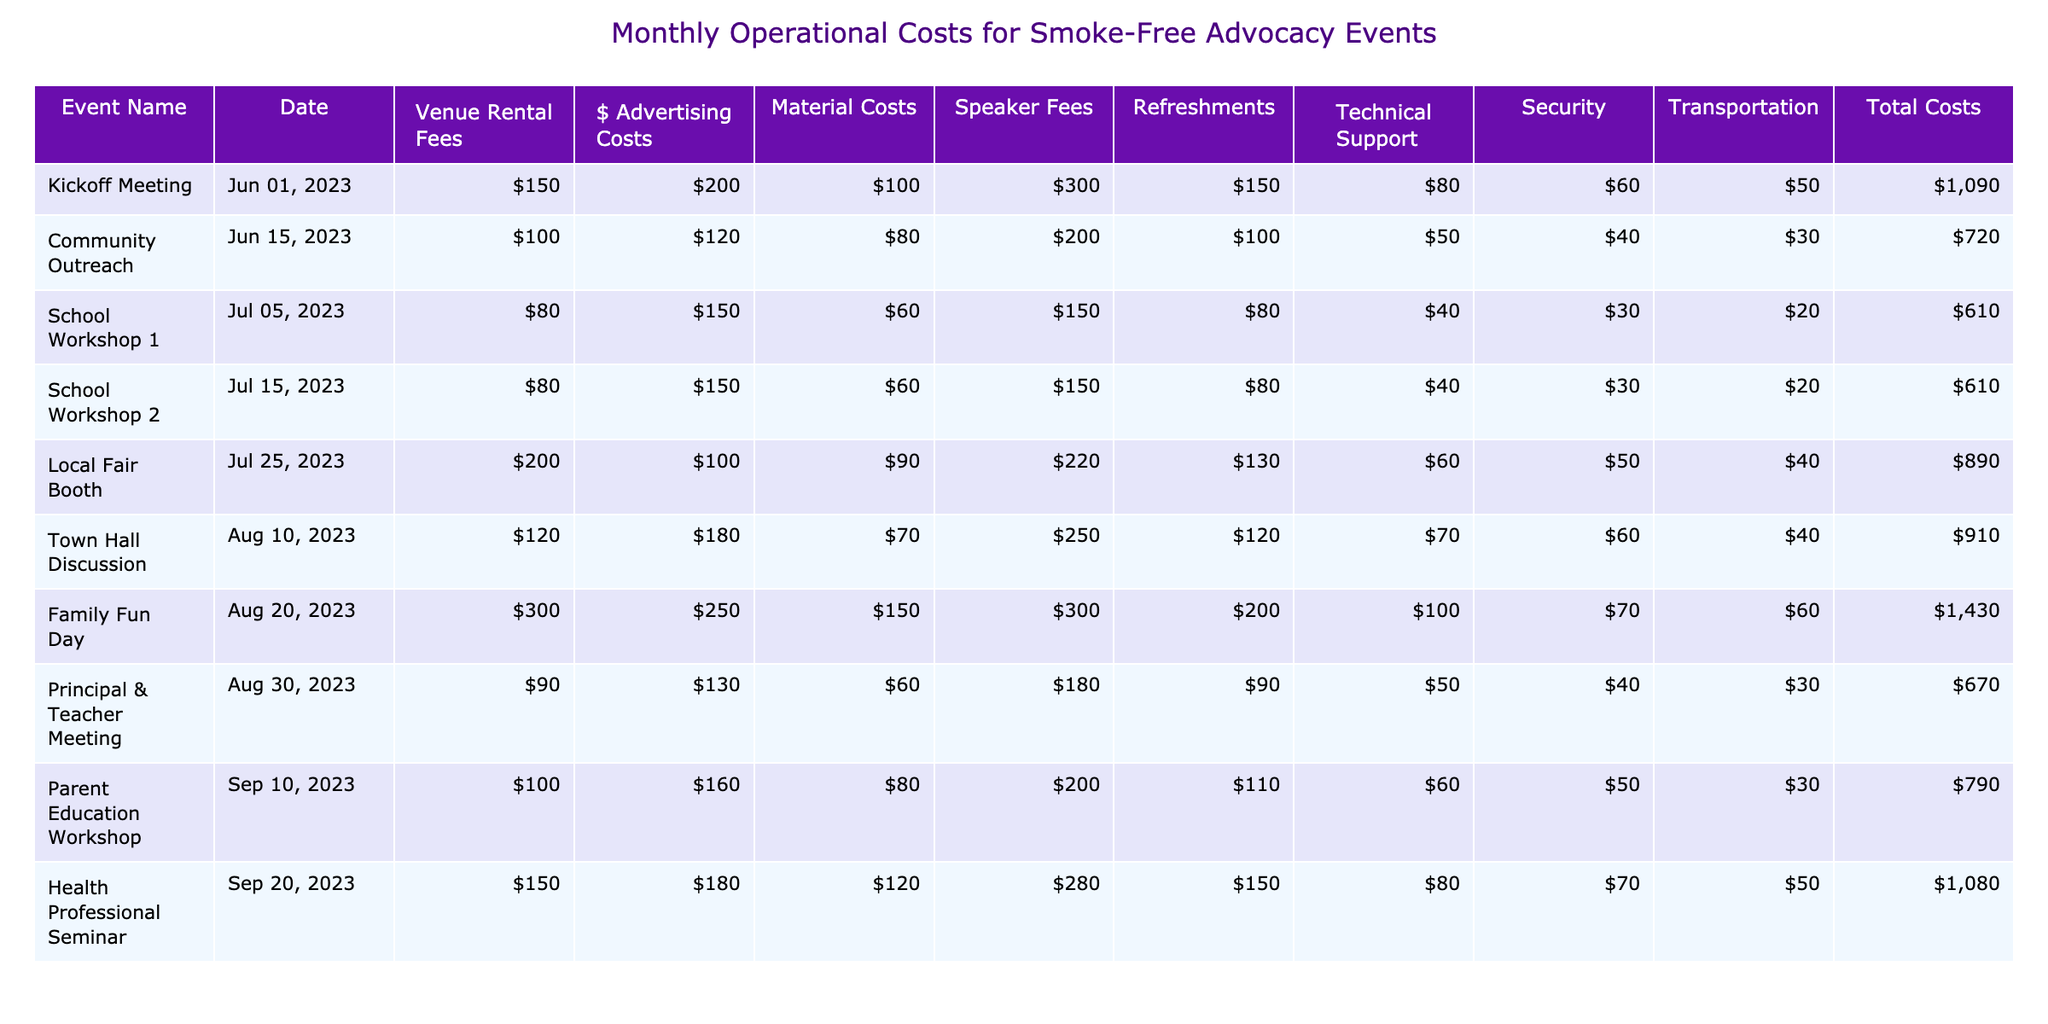What was the total cost for the Family Fun Day event? The table lists the total cost for each event. For the Family Fun Day, the Total Costs column shows a value of 1430.
Answer: 1430 Which event had the highest refreshment costs? From the Refreshments column, I look for the highest number. The Family Fun Day has the highest at 200.
Answer: 200 How much did the School Workshops cost combined? I sum the Total Costs of the two School Workshops. School Workshop 1 is 610 and School Workshop 2 is also 610. So, total cost is 610 + 610 = 1220.
Answer: 1220 Did the Kickoff Meeting cost more than the Town Hall Discussion? I compare the Total Costs for both events. The Kickoff Meeting cost 1090, while the Town Hall Discussion cost 910. Since 1090 is greater than 910, the statement is true.
Answer: Yes What is the average cost of all events listed? To find the average, I sum up all the Total Costs: 1090 + 720 + 610 + 610 + 890 + 910 + 1430 + 670 + 790 + 1080 = 1010. Then, I divide by the number of events, which is 10, giving an average of 10100 / 10 = 1010.
Answer: 1010 Which event’s advertising costs were least, and what was that amount? I examine the Advertising Costs column for the lowest value. The Community Outreach event has the least at 120.
Answer: 120 How many events had total costs exceeding 1000? I check each event's Total Costs and find that the Family Fun Day (1430), Kickoff Meeting (1090), and Health Professional Seminar (1080) are the only ones above 1000. This makes a total of three events.
Answer: 3 Is the total sum of venue rental fees for all events greater than 1000? I sum the Venue Rental Fees: 150 + 100 + 80 + 80 + 200 + 120 + 300 + 90 + 100 + 150 = 1370. Since 1370 is greater than 1000, the answer is true.
Answer: Yes What was the cost difference in technical support between the Family Fun Day and the School Workshop 1? I find Technical Support costs for both events: Family Fun Day is 200 and School Workshop 1 is 80. The difference is 200 - 80 = 120.
Answer: 120 